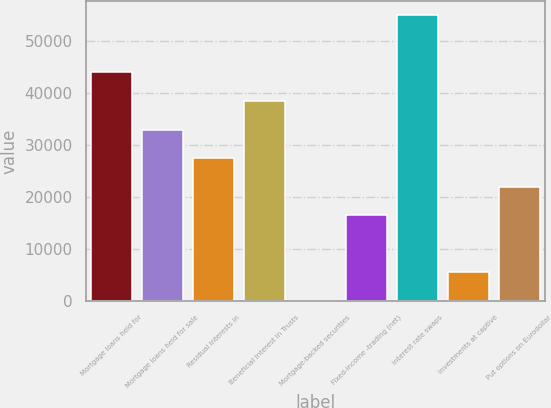Convert chart to OTSL. <chart><loc_0><loc_0><loc_500><loc_500><bar_chart><fcel>Mortgage loans held for<fcel>Mortgage loans held for sale<fcel>Residual interests in<fcel>Beneficial interest in Trusts<fcel>Mortgage-backed securities<fcel>Fixed-income -trading (net)<fcel>Interest rate swaps<fcel>Investments at captive<fcel>Put options on Eurodollar<nl><fcel>44012.6<fcel>33018.2<fcel>27521<fcel>38515.4<fcel>35<fcel>16526.6<fcel>55007<fcel>5532.2<fcel>22023.8<nl></chart> 